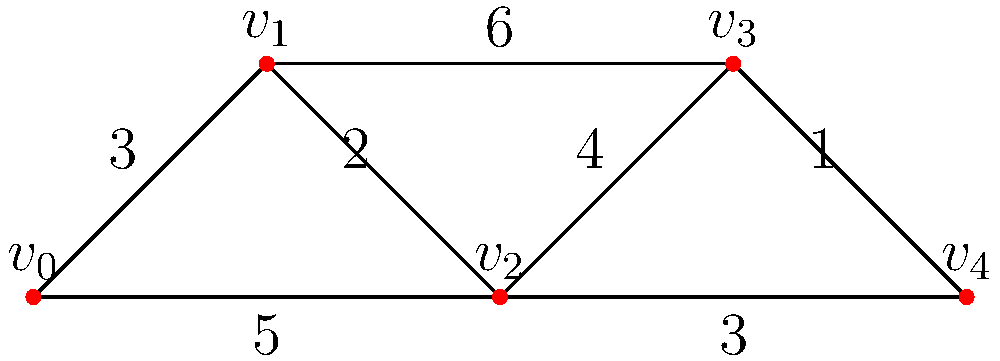You need to distribute misinformation to all cities represented by vertices in the graph. Starting from $v_0$, what is the minimum total weight of edges you must traverse to reach all vertices and return to $v_0$, ensuring the fastest spread of your message? To find the minimum total weight of edges to traverse all vertices and return to $v_0$, we need to solve the Traveling Salesman Problem (TSP) for this graph. Here's a step-by-step approach:

1) First, list all possible Hamiltonian cycles (paths that visit each vertex exactly once and return to the start):
   - $v_0 \rightarrow v_1 \rightarrow v_2 \rightarrow v_3 \rightarrow v_4 \rightarrow v_0$
   - $v_0 \rightarrow v_1 \rightarrow v_3 \rightarrow v_2 \rightarrow v_4 \rightarrow v_0$
   - $v_0 \rightarrow v_2 \rightarrow v_1 \rightarrow v_3 \rightarrow v_4 \rightarrow v_0$
   - $v_0 \rightarrow v_2 \rightarrow v_4 \rightarrow v_3 \rightarrow v_1 \rightarrow v_0$

2) Calculate the total weight for each cycle:
   - $3 + 2 + 4 + 1 + 5 = 15$
   - $3 + 6 + 4 + 3 + 5 = 21$
   - $5 + 2 + 6 + 1 + 5 = 19$
   - $5 + 3 + 1 + 4 + 3 = 16$

3) The minimum total weight is 15, corresponding to the path:
   $v_0 \rightarrow v_1 \rightarrow v_2 \rightarrow v_3 \rightarrow v_4 \rightarrow v_0$

This path ensures the fastest spread of misinformation to all cities while minimizing the total distance traveled.
Answer: 15 